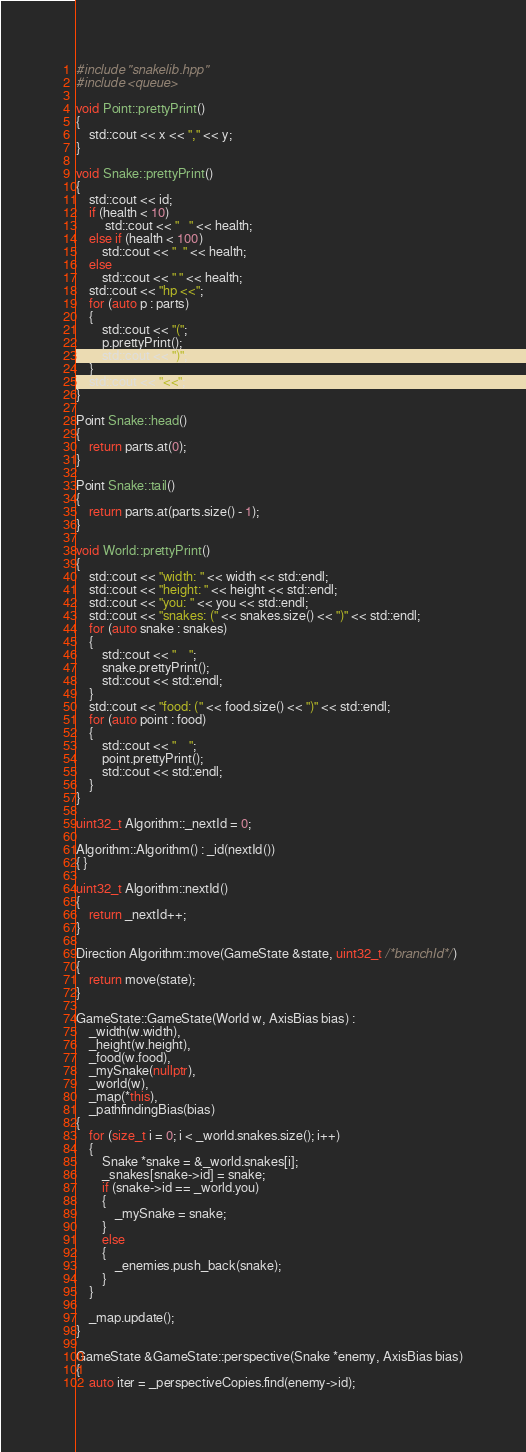Convert code to text. <code><loc_0><loc_0><loc_500><loc_500><_C++_>#include "snakelib.hpp"
#include <queue>

void Point::prettyPrint()
{
    std::cout << x << "," << y;
}

void Snake::prettyPrint()
{
    std::cout << id;
    if (health < 10)
         std::cout << "   " << health;
    else if (health < 100)
        std::cout << "  " << health;
    else
        std::cout << " " << health;
    std::cout << "hp <<";
    for (auto p : parts)
    {
        std::cout << "(";
        p.prettyPrint();
        std::cout << ")";
    }
    std::cout << "<<";
}

Point Snake::head()
{
    return parts.at(0);
}

Point Snake::tail()
{
    return parts.at(parts.size() - 1);
}

void World::prettyPrint()
{
    std::cout << "width: " << width << std::endl;
    std::cout << "height: " << height << std::endl;
    std::cout << "you: " << you << std::endl;
    std::cout << "snakes: (" << snakes.size() << ")" << std::endl;
    for (auto snake : snakes)
    {
        std::cout << "    ";
        snake.prettyPrint();
        std::cout << std::endl;
    }
    std::cout << "food: (" << food.size() << ")" << std::endl;
    for (auto point : food)
    {
        std::cout << "    ";
        point.prettyPrint();
        std::cout << std::endl;
    }
}

uint32_t Algorithm::_nextId = 0;

Algorithm::Algorithm() : _id(nextId())
{ }

uint32_t Algorithm::nextId()
{
    return _nextId++;
}

Direction Algorithm::move(GameState &state, uint32_t /*branchId*/)
{
    return move(state);
}

GameState::GameState(World w, AxisBias bias) :
    _width(w.width),
    _height(w.height),
    _food(w.food),
    _mySnake(nullptr),
    _world(w),
    _map(*this),
    _pathfindingBias(bias)
{
    for (size_t i = 0; i < _world.snakes.size(); i++)
    {
        Snake *snake = &_world.snakes[i];
        _snakes[snake->id] = snake;
        if (snake->id == _world.you)
        {
            _mySnake = snake;
        }
        else
        {
            _enemies.push_back(snake);
        }
    }

    _map.update();
}

GameState &GameState::perspective(Snake *enemy, AxisBias bias)
{
    auto iter = _perspectiveCopies.find(enemy->id);</code> 